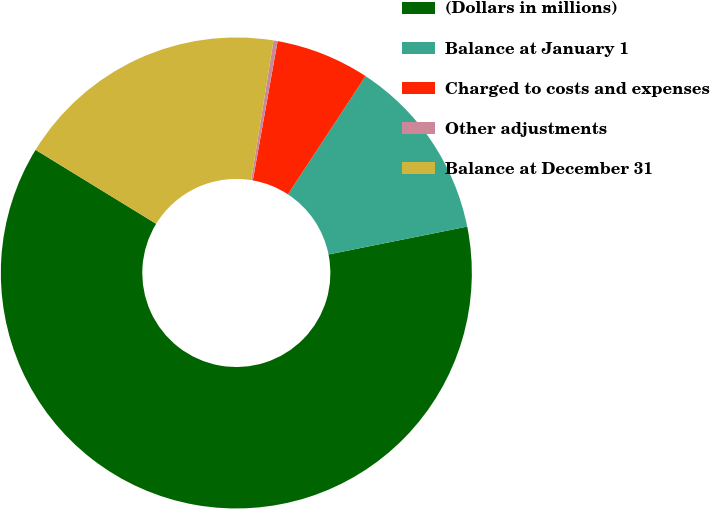Convert chart. <chart><loc_0><loc_0><loc_500><loc_500><pie_chart><fcel>(Dollars in millions)<fcel>Balance at January 1<fcel>Charged to costs and expenses<fcel>Other adjustments<fcel>Balance at December 31<nl><fcel>61.91%<fcel>12.6%<fcel>6.44%<fcel>0.28%<fcel>18.77%<nl></chart> 